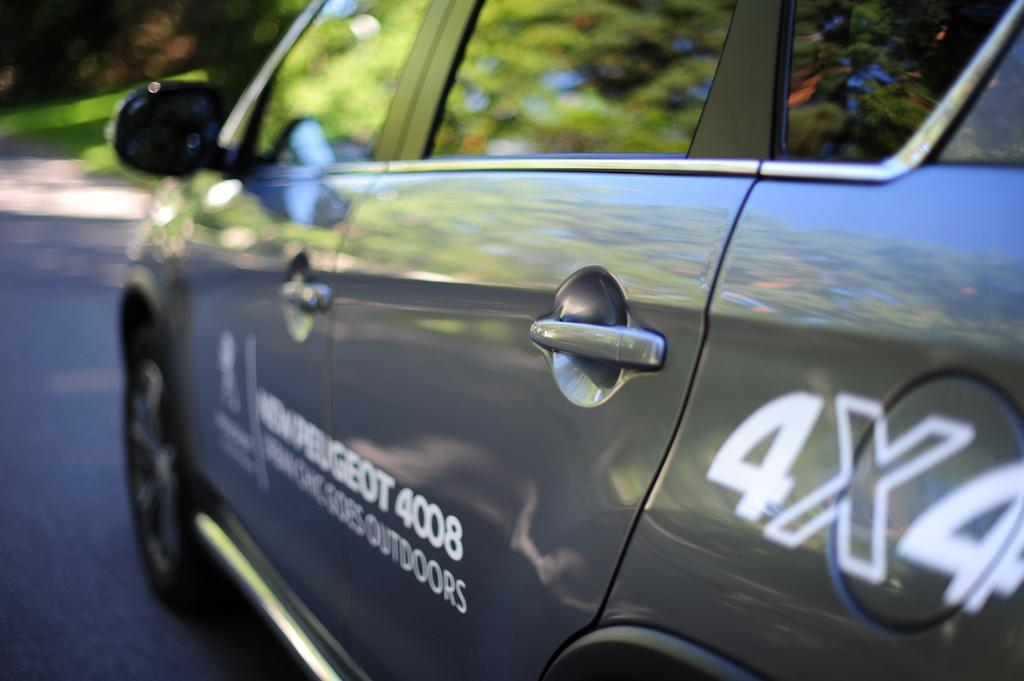What is the main subject of the image? The main subject of the image is a car. Where is the car located in the image? The car is on the road. Can you tell me how many firemen are standing next to the car in the image? There is no fireman present in the image; it only features a car on the road. What type of squirrel can be seen climbing the car in the image? There is no squirrel present in the image; it only features a car on the road. 